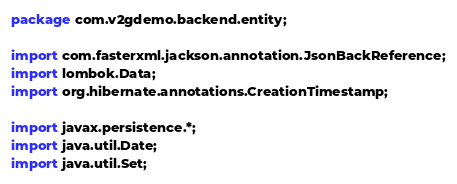<code> <loc_0><loc_0><loc_500><loc_500><_Java_>package com.v2gdemo.backend.entity;

import com.fasterxml.jackson.annotation.JsonBackReference;
import lombok.Data;
import org.hibernate.annotations.CreationTimestamp;

import javax.persistence.*;
import java.util.Date;
import java.util.Set;
</code> 